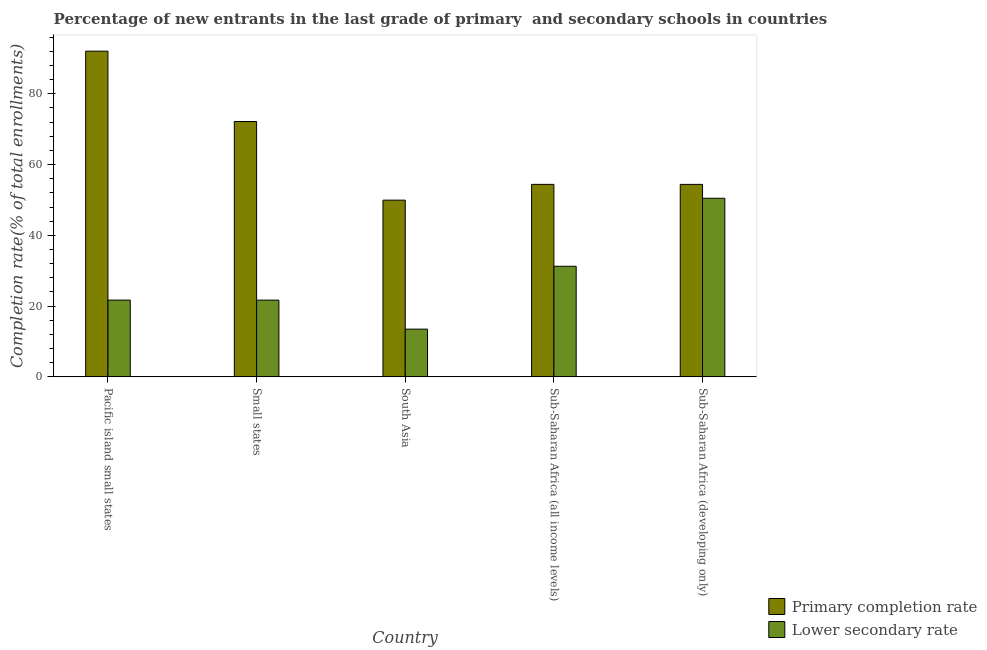How many groups of bars are there?
Ensure brevity in your answer.  5. Are the number of bars per tick equal to the number of legend labels?
Give a very brief answer. Yes. How many bars are there on the 3rd tick from the right?
Your answer should be compact. 2. What is the label of the 2nd group of bars from the left?
Keep it short and to the point. Small states. What is the completion rate in secondary schools in South Asia?
Your answer should be compact. 13.49. Across all countries, what is the maximum completion rate in primary schools?
Provide a short and direct response. 92.04. Across all countries, what is the minimum completion rate in primary schools?
Offer a terse response. 49.94. In which country was the completion rate in primary schools maximum?
Offer a terse response. Pacific island small states. What is the total completion rate in secondary schools in the graph?
Offer a very short reply. 138.6. What is the difference between the completion rate in secondary schools in Small states and that in Sub-Saharan Africa (developing only)?
Ensure brevity in your answer.  -28.78. What is the difference between the completion rate in primary schools in Small states and the completion rate in secondary schools in South Asia?
Provide a succinct answer. 58.67. What is the average completion rate in primary schools per country?
Give a very brief answer. 64.59. What is the difference between the completion rate in primary schools and completion rate in secondary schools in Sub-Saharan Africa (developing only)?
Keep it short and to the point. 3.92. What is the ratio of the completion rate in secondary schools in Pacific island small states to that in Small states?
Your answer should be compact. 1. What is the difference between the highest and the second highest completion rate in secondary schools?
Offer a terse response. 19.22. What is the difference between the highest and the lowest completion rate in secondary schools?
Ensure brevity in your answer.  36.98. What does the 2nd bar from the left in Pacific island small states represents?
Provide a succinct answer. Lower secondary rate. What does the 1st bar from the right in South Asia represents?
Offer a terse response. Lower secondary rate. How many bars are there?
Your answer should be very brief. 10. How many countries are there in the graph?
Make the answer very short. 5. What is the difference between two consecutive major ticks on the Y-axis?
Offer a terse response. 20. Are the values on the major ticks of Y-axis written in scientific E-notation?
Ensure brevity in your answer.  No. Does the graph contain any zero values?
Provide a succinct answer. No. Does the graph contain grids?
Your response must be concise. No. Where does the legend appear in the graph?
Offer a terse response. Bottom right. How many legend labels are there?
Your response must be concise. 2. What is the title of the graph?
Your answer should be compact. Percentage of new entrants in the last grade of primary  and secondary schools in countries. Does "Export" appear as one of the legend labels in the graph?
Ensure brevity in your answer.  No. What is the label or title of the Y-axis?
Provide a succinct answer. Completion rate(% of total enrollments). What is the Completion rate(% of total enrollments) of Primary completion rate in Pacific island small states?
Keep it short and to the point. 92.04. What is the Completion rate(% of total enrollments) in Lower secondary rate in Pacific island small states?
Offer a very short reply. 21.7. What is the Completion rate(% of total enrollments) of Primary completion rate in Small states?
Give a very brief answer. 72.16. What is the Completion rate(% of total enrollments) in Lower secondary rate in Small states?
Give a very brief answer. 21.69. What is the Completion rate(% of total enrollments) in Primary completion rate in South Asia?
Provide a succinct answer. 49.94. What is the Completion rate(% of total enrollments) of Lower secondary rate in South Asia?
Your answer should be compact. 13.49. What is the Completion rate(% of total enrollments) of Primary completion rate in Sub-Saharan Africa (all income levels)?
Your answer should be very brief. 54.4. What is the Completion rate(% of total enrollments) in Lower secondary rate in Sub-Saharan Africa (all income levels)?
Your answer should be very brief. 31.25. What is the Completion rate(% of total enrollments) in Primary completion rate in Sub-Saharan Africa (developing only)?
Your response must be concise. 54.39. What is the Completion rate(% of total enrollments) of Lower secondary rate in Sub-Saharan Africa (developing only)?
Provide a short and direct response. 50.47. Across all countries, what is the maximum Completion rate(% of total enrollments) of Primary completion rate?
Provide a short and direct response. 92.04. Across all countries, what is the maximum Completion rate(% of total enrollments) of Lower secondary rate?
Offer a terse response. 50.47. Across all countries, what is the minimum Completion rate(% of total enrollments) in Primary completion rate?
Your answer should be very brief. 49.94. Across all countries, what is the minimum Completion rate(% of total enrollments) of Lower secondary rate?
Keep it short and to the point. 13.49. What is the total Completion rate(% of total enrollments) in Primary completion rate in the graph?
Make the answer very short. 322.93. What is the total Completion rate(% of total enrollments) in Lower secondary rate in the graph?
Keep it short and to the point. 138.6. What is the difference between the Completion rate(% of total enrollments) in Primary completion rate in Pacific island small states and that in Small states?
Your response must be concise. 19.88. What is the difference between the Completion rate(% of total enrollments) in Lower secondary rate in Pacific island small states and that in Small states?
Provide a short and direct response. 0.01. What is the difference between the Completion rate(% of total enrollments) in Primary completion rate in Pacific island small states and that in South Asia?
Ensure brevity in your answer.  42.1. What is the difference between the Completion rate(% of total enrollments) in Lower secondary rate in Pacific island small states and that in South Asia?
Provide a short and direct response. 8.21. What is the difference between the Completion rate(% of total enrollments) in Primary completion rate in Pacific island small states and that in Sub-Saharan Africa (all income levels)?
Your response must be concise. 37.64. What is the difference between the Completion rate(% of total enrollments) in Lower secondary rate in Pacific island small states and that in Sub-Saharan Africa (all income levels)?
Keep it short and to the point. -9.55. What is the difference between the Completion rate(% of total enrollments) of Primary completion rate in Pacific island small states and that in Sub-Saharan Africa (developing only)?
Your answer should be compact. 37.65. What is the difference between the Completion rate(% of total enrollments) of Lower secondary rate in Pacific island small states and that in Sub-Saharan Africa (developing only)?
Keep it short and to the point. -28.77. What is the difference between the Completion rate(% of total enrollments) of Primary completion rate in Small states and that in South Asia?
Offer a terse response. 22.22. What is the difference between the Completion rate(% of total enrollments) in Lower secondary rate in Small states and that in South Asia?
Ensure brevity in your answer.  8.2. What is the difference between the Completion rate(% of total enrollments) in Primary completion rate in Small states and that in Sub-Saharan Africa (all income levels)?
Give a very brief answer. 17.76. What is the difference between the Completion rate(% of total enrollments) in Lower secondary rate in Small states and that in Sub-Saharan Africa (all income levels)?
Ensure brevity in your answer.  -9.56. What is the difference between the Completion rate(% of total enrollments) in Primary completion rate in Small states and that in Sub-Saharan Africa (developing only)?
Make the answer very short. 17.77. What is the difference between the Completion rate(% of total enrollments) in Lower secondary rate in Small states and that in Sub-Saharan Africa (developing only)?
Your response must be concise. -28.78. What is the difference between the Completion rate(% of total enrollments) in Primary completion rate in South Asia and that in Sub-Saharan Africa (all income levels)?
Your answer should be compact. -4.46. What is the difference between the Completion rate(% of total enrollments) in Lower secondary rate in South Asia and that in Sub-Saharan Africa (all income levels)?
Give a very brief answer. -17.76. What is the difference between the Completion rate(% of total enrollments) of Primary completion rate in South Asia and that in Sub-Saharan Africa (developing only)?
Your answer should be compact. -4.46. What is the difference between the Completion rate(% of total enrollments) of Lower secondary rate in South Asia and that in Sub-Saharan Africa (developing only)?
Provide a short and direct response. -36.98. What is the difference between the Completion rate(% of total enrollments) of Primary completion rate in Sub-Saharan Africa (all income levels) and that in Sub-Saharan Africa (developing only)?
Your response must be concise. 0.01. What is the difference between the Completion rate(% of total enrollments) of Lower secondary rate in Sub-Saharan Africa (all income levels) and that in Sub-Saharan Africa (developing only)?
Give a very brief answer. -19.22. What is the difference between the Completion rate(% of total enrollments) of Primary completion rate in Pacific island small states and the Completion rate(% of total enrollments) of Lower secondary rate in Small states?
Make the answer very short. 70.35. What is the difference between the Completion rate(% of total enrollments) in Primary completion rate in Pacific island small states and the Completion rate(% of total enrollments) in Lower secondary rate in South Asia?
Give a very brief answer. 78.55. What is the difference between the Completion rate(% of total enrollments) in Primary completion rate in Pacific island small states and the Completion rate(% of total enrollments) in Lower secondary rate in Sub-Saharan Africa (all income levels)?
Provide a short and direct response. 60.79. What is the difference between the Completion rate(% of total enrollments) of Primary completion rate in Pacific island small states and the Completion rate(% of total enrollments) of Lower secondary rate in Sub-Saharan Africa (developing only)?
Give a very brief answer. 41.57. What is the difference between the Completion rate(% of total enrollments) in Primary completion rate in Small states and the Completion rate(% of total enrollments) in Lower secondary rate in South Asia?
Provide a short and direct response. 58.67. What is the difference between the Completion rate(% of total enrollments) of Primary completion rate in Small states and the Completion rate(% of total enrollments) of Lower secondary rate in Sub-Saharan Africa (all income levels)?
Offer a terse response. 40.91. What is the difference between the Completion rate(% of total enrollments) of Primary completion rate in Small states and the Completion rate(% of total enrollments) of Lower secondary rate in Sub-Saharan Africa (developing only)?
Your answer should be compact. 21.69. What is the difference between the Completion rate(% of total enrollments) in Primary completion rate in South Asia and the Completion rate(% of total enrollments) in Lower secondary rate in Sub-Saharan Africa (all income levels)?
Offer a very short reply. 18.69. What is the difference between the Completion rate(% of total enrollments) of Primary completion rate in South Asia and the Completion rate(% of total enrollments) of Lower secondary rate in Sub-Saharan Africa (developing only)?
Make the answer very short. -0.54. What is the difference between the Completion rate(% of total enrollments) in Primary completion rate in Sub-Saharan Africa (all income levels) and the Completion rate(% of total enrollments) in Lower secondary rate in Sub-Saharan Africa (developing only)?
Ensure brevity in your answer.  3.93. What is the average Completion rate(% of total enrollments) in Primary completion rate per country?
Offer a terse response. 64.59. What is the average Completion rate(% of total enrollments) of Lower secondary rate per country?
Offer a terse response. 27.72. What is the difference between the Completion rate(% of total enrollments) of Primary completion rate and Completion rate(% of total enrollments) of Lower secondary rate in Pacific island small states?
Offer a terse response. 70.34. What is the difference between the Completion rate(% of total enrollments) in Primary completion rate and Completion rate(% of total enrollments) in Lower secondary rate in Small states?
Offer a terse response. 50.47. What is the difference between the Completion rate(% of total enrollments) in Primary completion rate and Completion rate(% of total enrollments) in Lower secondary rate in South Asia?
Ensure brevity in your answer.  36.45. What is the difference between the Completion rate(% of total enrollments) in Primary completion rate and Completion rate(% of total enrollments) in Lower secondary rate in Sub-Saharan Africa (all income levels)?
Your answer should be very brief. 23.15. What is the difference between the Completion rate(% of total enrollments) in Primary completion rate and Completion rate(% of total enrollments) in Lower secondary rate in Sub-Saharan Africa (developing only)?
Keep it short and to the point. 3.92. What is the ratio of the Completion rate(% of total enrollments) in Primary completion rate in Pacific island small states to that in Small states?
Offer a very short reply. 1.28. What is the ratio of the Completion rate(% of total enrollments) in Primary completion rate in Pacific island small states to that in South Asia?
Provide a short and direct response. 1.84. What is the ratio of the Completion rate(% of total enrollments) of Lower secondary rate in Pacific island small states to that in South Asia?
Give a very brief answer. 1.61. What is the ratio of the Completion rate(% of total enrollments) of Primary completion rate in Pacific island small states to that in Sub-Saharan Africa (all income levels)?
Make the answer very short. 1.69. What is the ratio of the Completion rate(% of total enrollments) of Lower secondary rate in Pacific island small states to that in Sub-Saharan Africa (all income levels)?
Make the answer very short. 0.69. What is the ratio of the Completion rate(% of total enrollments) in Primary completion rate in Pacific island small states to that in Sub-Saharan Africa (developing only)?
Your answer should be very brief. 1.69. What is the ratio of the Completion rate(% of total enrollments) in Lower secondary rate in Pacific island small states to that in Sub-Saharan Africa (developing only)?
Give a very brief answer. 0.43. What is the ratio of the Completion rate(% of total enrollments) in Primary completion rate in Small states to that in South Asia?
Ensure brevity in your answer.  1.45. What is the ratio of the Completion rate(% of total enrollments) of Lower secondary rate in Small states to that in South Asia?
Your answer should be very brief. 1.61. What is the ratio of the Completion rate(% of total enrollments) of Primary completion rate in Small states to that in Sub-Saharan Africa (all income levels)?
Keep it short and to the point. 1.33. What is the ratio of the Completion rate(% of total enrollments) of Lower secondary rate in Small states to that in Sub-Saharan Africa (all income levels)?
Ensure brevity in your answer.  0.69. What is the ratio of the Completion rate(% of total enrollments) in Primary completion rate in Small states to that in Sub-Saharan Africa (developing only)?
Offer a very short reply. 1.33. What is the ratio of the Completion rate(% of total enrollments) of Lower secondary rate in Small states to that in Sub-Saharan Africa (developing only)?
Your answer should be compact. 0.43. What is the ratio of the Completion rate(% of total enrollments) of Primary completion rate in South Asia to that in Sub-Saharan Africa (all income levels)?
Offer a terse response. 0.92. What is the ratio of the Completion rate(% of total enrollments) of Lower secondary rate in South Asia to that in Sub-Saharan Africa (all income levels)?
Your response must be concise. 0.43. What is the ratio of the Completion rate(% of total enrollments) of Primary completion rate in South Asia to that in Sub-Saharan Africa (developing only)?
Your answer should be very brief. 0.92. What is the ratio of the Completion rate(% of total enrollments) of Lower secondary rate in South Asia to that in Sub-Saharan Africa (developing only)?
Your answer should be very brief. 0.27. What is the ratio of the Completion rate(% of total enrollments) of Primary completion rate in Sub-Saharan Africa (all income levels) to that in Sub-Saharan Africa (developing only)?
Keep it short and to the point. 1. What is the ratio of the Completion rate(% of total enrollments) of Lower secondary rate in Sub-Saharan Africa (all income levels) to that in Sub-Saharan Africa (developing only)?
Provide a succinct answer. 0.62. What is the difference between the highest and the second highest Completion rate(% of total enrollments) in Primary completion rate?
Make the answer very short. 19.88. What is the difference between the highest and the second highest Completion rate(% of total enrollments) in Lower secondary rate?
Your answer should be compact. 19.22. What is the difference between the highest and the lowest Completion rate(% of total enrollments) of Primary completion rate?
Provide a succinct answer. 42.1. What is the difference between the highest and the lowest Completion rate(% of total enrollments) in Lower secondary rate?
Provide a succinct answer. 36.98. 